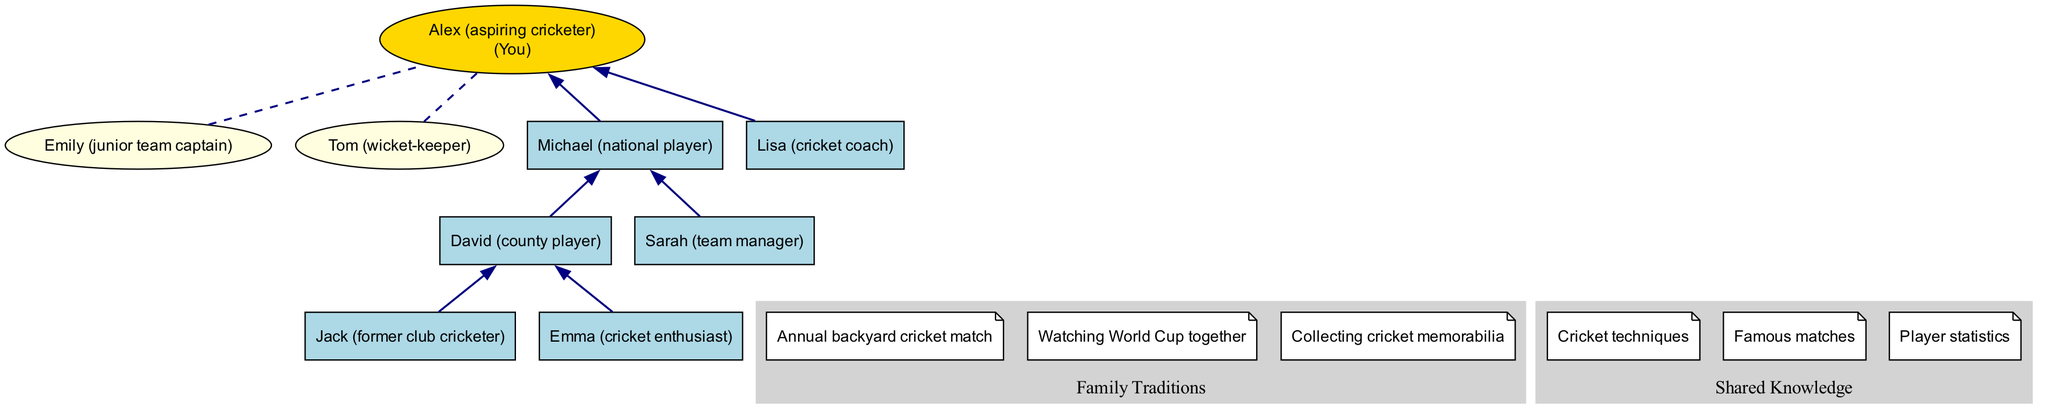What are the names of the great-grandparents? The diagram lists the great-grandparents as Jack and Emma. There are two nodes under "Great-Grandparents," and their names are clearly indicated.
Answer: Jack, Emma How many grandparents are shown in the diagram? The diagram has two grandparents, David and Sarah. This can be determined by counting the nodes under "Grandparents."
Answer: 2 What is the relation of Michael to Alex? Michael is listed under "Parents," which indicates he is Alex's father. The edge connecting "Parent0" (Michael) to "Teenager" (Alex) confirms this relationship.
Answer: Father Which family tradition involves outdoor play? The tradition of "Annual backyard cricket match" clearly indicates outdoor play. It is one of the nodes under "Family Traditions."
Answer: Annual backyard cricket match Who is the team's manager in the grandparents' generation? The diagram identifies Sarah as "team manager." This information is found in the node associated with the grandparents.
Answer: Sarah What is a shared knowledge area among the family? "Cricket techniques" is one of the areas of shared knowledge listed in the diagram. This insight comes from the nodes under "Shared Knowledge."
Answer: Cricket techniques How many siblings does Alex have? The diagram shows that there are two siblings listed under "Siblings" (Emily and Tom). This is confirmed by counting the nodes in that section.
Answer: 2 Who among the parents is involved in coaching? The node for Lisa states she is "cricket coach," indicating her role in coaching within the parents' generation. This can be read directly from the diagram under "Parents."
Answer: Lisa How many family traditions are depicted in the diagram? There are three family traditions indicated: "Annual backyard cricket match," "Watching World Cup together," and "Collecting cricket memorabilia." This is determined by counting the nodes under "Family Traditions."
Answer: 3 